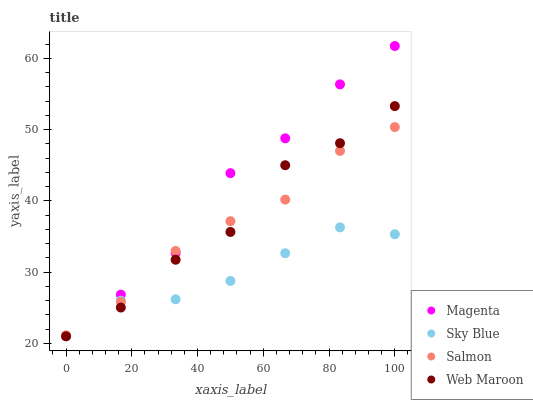Does Sky Blue have the minimum area under the curve?
Answer yes or no. Yes. Does Magenta have the maximum area under the curve?
Answer yes or no. Yes. Does Salmon have the minimum area under the curve?
Answer yes or no. No. Does Salmon have the maximum area under the curve?
Answer yes or no. No. Is Sky Blue the smoothest?
Answer yes or no. Yes. Is Web Maroon the roughest?
Answer yes or no. Yes. Is Magenta the smoothest?
Answer yes or no. No. Is Magenta the roughest?
Answer yes or no. No. Does Sky Blue have the lowest value?
Answer yes or no. Yes. Does Salmon have the lowest value?
Answer yes or no. No. Does Magenta have the highest value?
Answer yes or no. Yes. Does Salmon have the highest value?
Answer yes or no. No. Does Sky Blue intersect Web Maroon?
Answer yes or no. Yes. Is Sky Blue less than Web Maroon?
Answer yes or no. No. Is Sky Blue greater than Web Maroon?
Answer yes or no. No. 